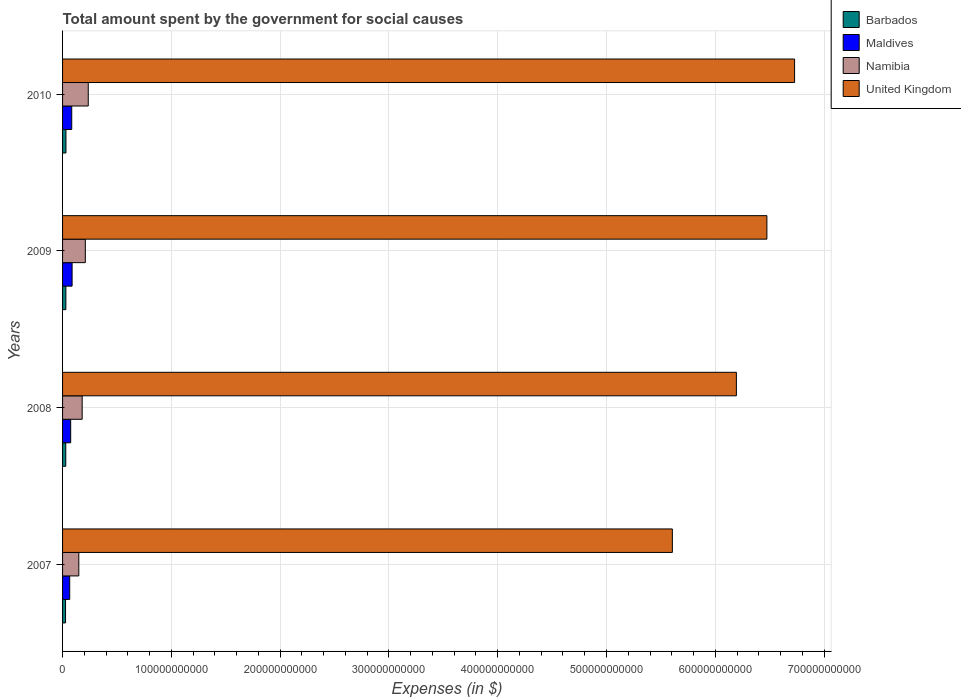How many different coloured bars are there?
Give a very brief answer. 4. Are the number of bars on each tick of the Y-axis equal?
Ensure brevity in your answer.  Yes. What is the amount spent for social causes by the government in Namibia in 2008?
Your response must be concise. 1.80e+1. Across all years, what is the maximum amount spent for social causes by the government in United Kingdom?
Make the answer very short. 6.73e+11. Across all years, what is the minimum amount spent for social causes by the government in United Kingdom?
Your response must be concise. 5.61e+11. In which year was the amount spent for social causes by the government in United Kingdom minimum?
Your answer should be compact. 2007. What is the total amount spent for social causes by the government in Barbados in the graph?
Your answer should be compact. 1.18e+1. What is the difference between the amount spent for social causes by the government in Barbados in 2009 and that in 2010?
Your answer should be compact. -7.68e+07. What is the difference between the amount spent for social causes by the government in Namibia in 2009 and the amount spent for social causes by the government in Maldives in 2008?
Your response must be concise. 1.35e+1. What is the average amount spent for social causes by the government in Barbados per year?
Provide a succinct answer. 2.96e+09. In the year 2010, what is the difference between the amount spent for social causes by the government in Namibia and amount spent for social causes by the government in Maldives?
Your answer should be very brief. 1.52e+1. In how many years, is the amount spent for social causes by the government in Namibia greater than 300000000000 $?
Provide a succinct answer. 0. What is the ratio of the amount spent for social causes by the government in Namibia in 2007 to that in 2009?
Your answer should be compact. 0.71. Is the difference between the amount spent for social causes by the government in Namibia in 2008 and 2009 greater than the difference between the amount spent for social causes by the government in Maldives in 2008 and 2009?
Your answer should be very brief. No. What is the difference between the highest and the second highest amount spent for social causes by the government in United Kingdom?
Offer a terse response. 2.55e+1. What is the difference between the highest and the lowest amount spent for social causes by the government in United Kingdom?
Offer a very short reply. 1.12e+11. Is the sum of the amount spent for social causes by the government in Barbados in 2007 and 2010 greater than the maximum amount spent for social causes by the government in Maldives across all years?
Ensure brevity in your answer.  No. What does the 1st bar from the top in 2009 represents?
Your response must be concise. United Kingdom. What is the difference between two consecutive major ticks on the X-axis?
Offer a very short reply. 1.00e+11. Are the values on the major ticks of X-axis written in scientific E-notation?
Your answer should be very brief. No. Does the graph contain grids?
Give a very brief answer. Yes. Where does the legend appear in the graph?
Offer a terse response. Top right. How are the legend labels stacked?
Provide a short and direct response. Vertical. What is the title of the graph?
Ensure brevity in your answer.  Total amount spent by the government for social causes. What is the label or title of the X-axis?
Your response must be concise. Expenses (in $). What is the Expenses (in $) in Barbados in 2007?
Offer a very short reply. 2.73e+09. What is the Expenses (in $) of Maldives in 2007?
Give a very brief answer. 6.56e+09. What is the Expenses (in $) of Namibia in 2007?
Offer a terse response. 1.49e+1. What is the Expenses (in $) in United Kingdom in 2007?
Keep it short and to the point. 5.61e+11. What is the Expenses (in $) of Barbados in 2008?
Your response must be concise. 2.96e+09. What is the Expenses (in $) of Maldives in 2008?
Ensure brevity in your answer.  7.46e+09. What is the Expenses (in $) of Namibia in 2008?
Your answer should be compact. 1.80e+1. What is the Expenses (in $) of United Kingdom in 2008?
Offer a terse response. 6.19e+11. What is the Expenses (in $) of Barbados in 2009?
Your answer should be very brief. 3.04e+09. What is the Expenses (in $) of Maldives in 2009?
Provide a short and direct response. 8.76e+09. What is the Expenses (in $) of Namibia in 2009?
Offer a terse response. 2.09e+1. What is the Expenses (in $) in United Kingdom in 2009?
Offer a very short reply. 6.47e+11. What is the Expenses (in $) in Barbados in 2010?
Your response must be concise. 3.11e+09. What is the Expenses (in $) in Maldives in 2010?
Your answer should be compact. 8.43e+09. What is the Expenses (in $) in Namibia in 2010?
Provide a succinct answer. 2.36e+1. What is the Expenses (in $) of United Kingdom in 2010?
Keep it short and to the point. 6.73e+11. Across all years, what is the maximum Expenses (in $) in Barbados?
Make the answer very short. 3.11e+09. Across all years, what is the maximum Expenses (in $) in Maldives?
Ensure brevity in your answer.  8.76e+09. Across all years, what is the maximum Expenses (in $) in Namibia?
Offer a terse response. 2.36e+1. Across all years, what is the maximum Expenses (in $) of United Kingdom?
Keep it short and to the point. 6.73e+11. Across all years, what is the minimum Expenses (in $) in Barbados?
Offer a terse response. 2.73e+09. Across all years, what is the minimum Expenses (in $) in Maldives?
Give a very brief answer. 6.56e+09. Across all years, what is the minimum Expenses (in $) of Namibia?
Your answer should be very brief. 1.49e+1. Across all years, what is the minimum Expenses (in $) in United Kingdom?
Give a very brief answer. 5.61e+11. What is the total Expenses (in $) of Barbados in the graph?
Provide a succinct answer. 1.18e+1. What is the total Expenses (in $) of Maldives in the graph?
Your answer should be very brief. 3.12e+1. What is the total Expenses (in $) in Namibia in the graph?
Offer a terse response. 7.75e+1. What is the total Expenses (in $) of United Kingdom in the graph?
Offer a very short reply. 2.50e+12. What is the difference between the Expenses (in $) in Barbados in 2007 and that in 2008?
Make the answer very short. -2.22e+08. What is the difference between the Expenses (in $) in Maldives in 2007 and that in 2008?
Make the answer very short. -9.03e+08. What is the difference between the Expenses (in $) of Namibia in 2007 and that in 2008?
Provide a succinct answer. -3.08e+09. What is the difference between the Expenses (in $) in United Kingdom in 2007 and that in 2008?
Offer a terse response. -5.89e+1. What is the difference between the Expenses (in $) of Barbados in 2007 and that in 2009?
Keep it short and to the point. -3.01e+08. What is the difference between the Expenses (in $) of Maldives in 2007 and that in 2009?
Offer a terse response. -2.20e+09. What is the difference between the Expenses (in $) of Namibia in 2007 and that in 2009?
Provide a succinct answer. -5.99e+09. What is the difference between the Expenses (in $) in United Kingdom in 2007 and that in 2009?
Your answer should be compact. -8.69e+1. What is the difference between the Expenses (in $) of Barbados in 2007 and that in 2010?
Make the answer very short. -3.77e+08. What is the difference between the Expenses (in $) in Maldives in 2007 and that in 2010?
Offer a terse response. -1.87e+09. What is the difference between the Expenses (in $) of Namibia in 2007 and that in 2010?
Keep it short and to the point. -8.67e+09. What is the difference between the Expenses (in $) of United Kingdom in 2007 and that in 2010?
Offer a very short reply. -1.12e+11. What is the difference between the Expenses (in $) in Barbados in 2008 and that in 2009?
Provide a short and direct response. -7.86e+07. What is the difference between the Expenses (in $) in Maldives in 2008 and that in 2009?
Provide a short and direct response. -1.30e+09. What is the difference between the Expenses (in $) of Namibia in 2008 and that in 2009?
Your answer should be very brief. -2.91e+09. What is the difference between the Expenses (in $) of United Kingdom in 2008 and that in 2009?
Your answer should be very brief. -2.80e+1. What is the difference between the Expenses (in $) of Barbados in 2008 and that in 2010?
Offer a very short reply. -1.55e+08. What is the difference between the Expenses (in $) in Maldives in 2008 and that in 2010?
Your response must be concise. -9.65e+08. What is the difference between the Expenses (in $) in Namibia in 2008 and that in 2010?
Make the answer very short. -5.59e+09. What is the difference between the Expenses (in $) of United Kingdom in 2008 and that in 2010?
Your answer should be very brief. -5.35e+1. What is the difference between the Expenses (in $) in Barbados in 2009 and that in 2010?
Provide a succinct answer. -7.68e+07. What is the difference between the Expenses (in $) of Maldives in 2009 and that in 2010?
Provide a succinct answer. 3.37e+08. What is the difference between the Expenses (in $) of Namibia in 2009 and that in 2010?
Keep it short and to the point. -2.68e+09. What is the difference between the Expenses (in $) of United Kingdom in 2009 and that in 2010?
Provide a short and direct response. -2.55e+1. What is the difference between the Expenses (in $) of Barbados in 2007 and the Expenses (in $) of Maldives in 2008?
Make the answer very short. -4.73e+09. What is the difference between the Expenses (in $) of Barbados in 2007 and the Expenses (in $) of Namibia in 2008?
Keep it short and to the point. -1.53e+1. What is the difference between the Expenses (in $) in Barbados in 2007 and the Expenses (in $) in United Kingdom in 2008?
Make the answer very short. -6.17e+11. What is the difference between the Expenses (in $) in Maldives in 2007 and the Expenses (in $) in Namibia in 2008?
Offer a very short reply. -1.15e+1. What is the difference between the Expenses (in $) in Maldives in 2007 and the Expenses (in $) in United Kingdom in 2008?
Ensure brevity in your answer.  -6.13e+11. What is the difference between the Expenses (in $) in Namibia in 2007 and the Expenses (in $) in United Kingdom in 2008?
Offer a very short reply. -6.04e+11. What is the difference between the Expenses (in $) in Barbados in 2007 and the Expenses (in $) in Maldives in 2009?
Make the answer very short. -6.03e+09. What is the difference between the Expenses (in $) in Barbados in 2007 and the Expenses (in $) in Namibia in 2009?
Offer a very short reply. -1.82e+1. What is the difference between the Expenses (in $) of Barbados in 2007 and the Expenses (in $) of United Kingdom in 2009?
Your answer should be compact. -6.45e+11. What is the difference between the Expenses (in $) of Maldives in 2007 and the Expenses (in $) of Namibia in 2009?
Keep it short and to the point. -1.44e+1. What is the difference between the Expenses (in $) in Maldives in 2007 and the Expenses (in $) in United Kingdom in 2009?
Your response must be concise. -6.41e+11. What is the difference between the Expenses (in $) of Namibia in 2007 and the Expenses (in $) of United Kingdom in 2009?
Offer a terse response. -6.33e+11. What is the difference between the Expenses (in $) in Barbados in 2007 and the Expenses (in $) in Maldives in 2010?
Ensure brevity in your answer.  -5.69e+09. What is the difference between the Expenses (in $) in Barbados in 2007 and the Expenses (in $) in Namibia in 2010?
Your response must be concise. -2.09e+1. What is the difference between the Expenses (in $) of Barbados in 2007 and the Expenses (in $) of United Kingdom in 2010?
Your answer should be compact. -6.70e+11. What is the difference between the Expenses (in $) in Maldives in 2007 and the Expenses (in $) in Namibia in 2010?
Your response must be concise. -1.70e+1. What is the difference between the Expenses (in $) of Maldives in 2007 and the Expenses (in $) of United Kingdom in 2010?
Offer a very short reply. -6.66e+11. What is the difference between the Expenses (in $) of Namibia in 2007 and the Expenses (in $) of United Kingdom in 2010?
Ensure brevity in your answer.  -6.58e+11. What is the difference between the Expenses (in $) in Barbados in 2008 and the Expenses (in $) in Maldives in 2009?
Make the answer very short. -5.81e+09. What is the difference between the Expenses (in $) of Barbados in 2008 and the Expenses (in $) of Namibia in 2009?
Ensure brevity in your answer.  -1.80e+1. What is the difference between the Expenses (in $) in Barbados in 2008 and the Expenses (in $) in United Kingdom in 2009?
Your answer should be very brief. -6.45e+11. What is the difference between the Expenses (in $) in Maldives in 2008 and the Expenses (in $) in Namibia in 2009?
Provide a short and direct response. -1.35e+1. What is the difference between the Expenses (in $) in Maldives in 2008 and the Expenses (in $) in United Kingdom in 2009?
Offer a very short reply. -6.40e+11. What is the difference between the Expenses (in $) of Namibia in 2008 and the Expenses (in $) of United Kingdom in 2009?
Your answer should be compact. -6.29e+11. What is the difference between the Expenses (in $) in Barbados in 2008 and the Expenses (in $) in Maldives in 2010?
Make the answer very short. -5.47e+09. What is the difference between the Expenses (in $) of Barbados in 2008 and the Expenses (in $) of Namibia in 2010?
Provide a short and direct response. -2.07e+1. What is the difference between the Expenses (in $) of Barbados in 2008 and the Expenses (in $) of United Kingdom in 2010?
Offer a very short reply. -6.70e+11. What is the difference between the Expenses (in $) of Maldives in 2008 and the Expenses (in $) of Namibia in 2010?
Your answer should be very brief. -1.61e+1. What is the difference between the Expenses (in $) in Maldives in 2008 and the Expenses (in $) in United Kingdom in 2010?
Your response must be concise. -6.65e+11. What is the difference between the Expenses (in $) in Namibia in 2008 and the Expenses (in $) in United Kingdom in 2010?
Give a very brief answer. -6.55e+11. What is the difference between the Expenses (in $) in Barbados in 2009 and the Expenses (in $) in Maldives in 2010?
Keep it short and to the point. -5.39e+09. What is the difference between the Expenses (in $) of Barbados in 2009 and the Expenses (in $) of Namibia in 2010?
Your response must be concise. -2.06e+1. What is the difference between the Expenses (in $) of Barbados in 2009 and the Expenses (in $) of United Kingdom in 2010?
Your answer should be very brief. -6.70e+11. What is the difference between the Expenses (in $) of Maldives in 2009 and the Expenses (in $) of Namibia in 2010?
Make the answer very short. -1.48e+1. What is the difference between the Expenses (in $) in Maldives in 2009 and the Expenses (in $) in United Kingdom in 2010?
Offer a terse response. -6.64e+11. What is the difference between the Expenses (in $) in Namibia in 2009 and the Expenses (in $) in United Kingdom in 2010?
Your answer should be compact. -6.52e+11. What is the average Expenses (in $) of Barbados per year?
Make the answer very short. 2.96e+09. What is the average Expenses (in $) in Maldives per year?
Your response must be concise. 7.80e+09. What is the average Expenses (in $) of Namibia per year?
Provide a short and direct response. 1.94e+1. What is the average Expenses (in $) of United Kingdom per year?
Your answer should be compact. 6.25e+11. In the year 2007, what is the difference between the Expenses (in $) in Barbados and Expenses (in $) in Maldives?
Your answer should be compact. -3.83e+09. In the year 2007, what is the difference between the Expenses (in $) in Barbados and Expenses (in $) in Namibia?
Ensure brevity in your answer.  -1.22e+1. In the year 2007, what is the difference between the Expenses (in $) of Barbados and Expenses (in $) of United Kingdom?
Your answer should be compact. -5.58e+11. In the year 2007, what is the difference between the Expenses (in $) in Maldives and Expenses (in $) in Namibia?
Make the answer very short. -8.38e+09. In the year 2007, what is the difference between the Expenses (in $) in Maldives and Expenses (in $) in United Kingdom?
Ensure brevity in your answer.  -5.54e+11. In the year 2007, what is the difference between the Expenses (in $) in Namibia and Expenses (in $) in United Kingdom?
Your answer should be very brief. -5.46e+11. In the year 2008, what is the difference between the Expenses (in $) of Barbados and Expenses (in $) of Maldives?
Offer a very short reply. -4.51e+09. In the year 2008, what is the difference between the Expenses (in $) of Barbados and Expenses (in $) of Namibia?
Keep it short and to the point. -1.51e+1. In the year 2008, what is the difference between the Expenses (in $) of Barbados and Expenses (in $) of United Kingdom?
Give a very brief answer. -6.16e+11. In the year 2008, what is the difference between the Expenses (in $) in Maldives and Expenses (in $) in Namibia?
Your response must be concise. -1.06e+1. In the year 2008, what is the difference between the Expenses (in $) in Maldives and Expenses (in $) in United Kingdom?
Offer a terse response. -6.12e+11. In the year 2008, what is the difference between the Expenses (in $) of Namibia and Expenses (in $) of United Kingdom?
Ensure brevity in your answer.  -6.01e+11. In the year 2009, what is the difference between the Expenses (in $) of Barbados and Expenses (in $) of Maldives?
Give a very brief answer. -5.73e+09. In the year 2009, what is the difference between the Expenses (in $) of Barbados and Expenses (in $) of Namibia?
Keep it short and to the point. -1.79e+1. In the year 2009, what is the difference between the Expenses (in $) in Barbados and Expenses (in $) in United Kingdom?
Ensure brevity in your answer.  -6.44e+11. In the year 2009, what is the difference between the Expenses (in $) of Maldives and Expenses (in $) of Namibia?
Give a very brief answer. -1.22e+1. In the year 2009, what is the difference between the Expenses (in $) of Maldives and Expenses (in $) of United Kingdom?
Offer a very short reply. -6.39e+11. In the year 2009, what is the difference between the Expenses (in $) in Namibia and Expenses (in $) in United Kingdom?
Offer a very short reply. -6.27e+11. In the year 2010, what is the difference between the Expenses (in $) of Barbados and Expenses (in $) of Maldives?
Provide a short and direct response. -5.32e+09. In the year 2010, what is the difference between the Expenses (in $) in Barbados and Expenses (in $) in Namibia?
Offer a terse response. -2.05e+1. In the year 2010, what is the difference between the Expenses (in $) in Barbados and Expenses (in $) in United Kingdom?
Keep it short and to the point. -6.70e+11. In the year 2010, what is the difference between the Expenses (in $) of Maldives and Expenses (in $) of Namibia?
Offer a terse response. -1.52e+1. In the year 2010, what is the difference between the Expenses (in $) of Maldives and Expenses (in $) of United Kingdom?
Provide a short and direct response. -6.64e+11. In the year 2010, what is the difference between the Expenses (in $) in Namibia and Expenses (in $) in United Kingdom?
Your answer should be very brief. -6.49e+11. What is the ratio of the Expenses (in $) of Barbados in 2007 to that in 2008?
Offer a terse response. 0.92. What is the ratio of the Expenses (in $) of Maldives in 2007 to that in 2008?
Make the answer very short. 0.88. What is the ratio of the Expenses (in $) in Namibia in 2007 to that in 2008?
Offer a very short reply. 0.83. What is the ratio of the Expenses (in $) of United Kingdom in 2007 to that in 2008?
Your answer should be compact. 0.91. What is the ratio of the Expenses (in $) of Barbados in 2007 to that in 2009?
Offer a very short reply. 0.9. What is the ratio of the Expenses (in $) in Maldives in 2007 to that in 2009?
Give a very brief answer. 0.75. What is the ratio of the Expenses (in $) in Namibia in 2007 to that in 2009?
Your answer should be very brief. 0.71. What is the ratio of the Expenses (in $) in United Kingdom in 2007 to that in 2009?
Your answer should be very brief. 0.87. What is the ratio of the Expenses (in $) in Barbados in 2007 to that in 2010?
Make the answer very short. 0.88. What is the ratio of the Expenses (in $) of Maldives in 2007 to that in 2010?
Your answer should be compact. 0.78. What is the ratio of the Expenses (in $) of Namibia in 2007 to that in 2010?
Your answer should be very brief. 0.63. What is the ratio of the Expenses (in $) in United Kingdom in 2007 to that in 2010?
Keep it short and to the point. 0.83. What is the ratio of the Expenses (in $) of Barbados in 2008 to that in 2009?
Keep it short and to the point. 0.97. What is the ratio of the Expenses (in $) of Maldives in 2008 to that in 2009?
Keep it short and to the point. 0.85. What is the ratio of the Expenses (in $) in Namibia in 2008 to that in 2009?
Offer a very short reply. 0.86. What is the ratio of the Expenses (in $) in United Kingdom in 2008 to that in 2009?
Keep it short and to the point. 0.96. What is the ratio of the Expenses (in $) in Barbados in 2008 to that in 2010?
Make the answer very short. 0.95. What is the ratio of the Expenses (in $) of Maldives in 2008 to that in 2010?
Your response must be concise. 0.89. What is the ratio of the Expenses (in $) of Namibia in 2008 to that in 2010?
Your answer should be compact. 0.76. What is the ratio of the Expenses (in $) of United Kingdom in 2008 to that in 2010?
Give a very brief answer. 0.92. What is the ratio of the Expenses (in $) of Barbados in 2009 to that in 2010?
Your answer should be compact. 0.98. What is the ratio of the Expenses (in $) in Namibia in 2009 to that in 2010?
Offer a very short reply. 0.89. What is the ratio of the Expenses (in $) of United Kingdom in 2009 to that in 2010?
Ensure brevity in your answer.  0.96. What is the difference between the highest and the second highest Expenses (in $) in Barbados?
Give a very brief answer. 7.68e+07. What is the difference between the highest and the second highest Expenses (in $) of Maldives?
Provide a succinct answer. 3.37e+08. What is the difference between the highest and the second highest Expenses (in $) in Namibia?
Your answer should be compact. 2.68e+09. What is the difference between the highest and the second highest Expenses (in $) of United Kingdom?
Keep it short and to the point. 2.55e+1. What is the difference between the highest and the lowest Expenses (in $) in Barbados?
Offer a terse response. 3.77e+08. What is the difference between the highest and the lowest Expenses (in $) in Maldives?
Offer a very short reply. 2.20e+09. What is the difference between the highest and the lowest Expenses (in $) in Namibia?
Ensure brevity in your answer.  8.67e+09. What is the difference between the highest and the lowest Expenses (in $) in United Kingdom?
Provide a short and direct response. 1.12e+11. 